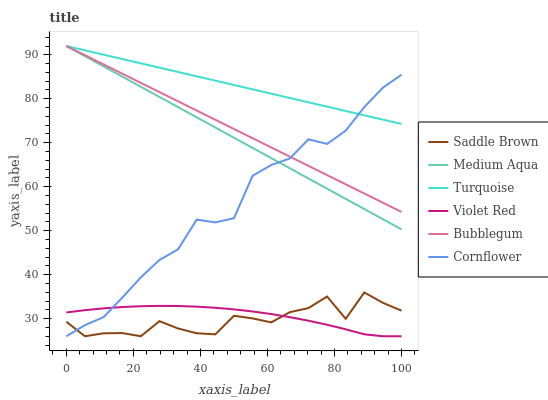Does Saddle Brown have the minimum area under the curve?
Answer yes or no. Yes. Does Turquoise have the maximum area under the curve?
Answer yes or no. Yes. Does Violet Red have the minimum area under the curve?
Answer yes or no. No. Does Violet Red have the maximum area under the curve?
Answer yes or no. No. Is Turquoise the smoothest?
Answer yes or no. Yes. Is Saddle Brown the roughest?
Answer yes or no. Yes. Is Violet Red the smoothest?
Answer yes or no. No. Is Violet Red the roughest?
Answer yes or no. No. Does Turquoise have the lowest value?
Answer yes or no. No. Does Medium Aqua have the highest value?
Answer yes or no. Yes. Does Violet Red have the highest value?
Answer yes or no. No. Is Violet Red less than Turquoise?
Answer yes or no. Yes. Is Bubblegum greater than Saddle Brown?
Answer yes or no. Yes. Does Violet Red intersect Turquoise?
Answer yes or no. No. 